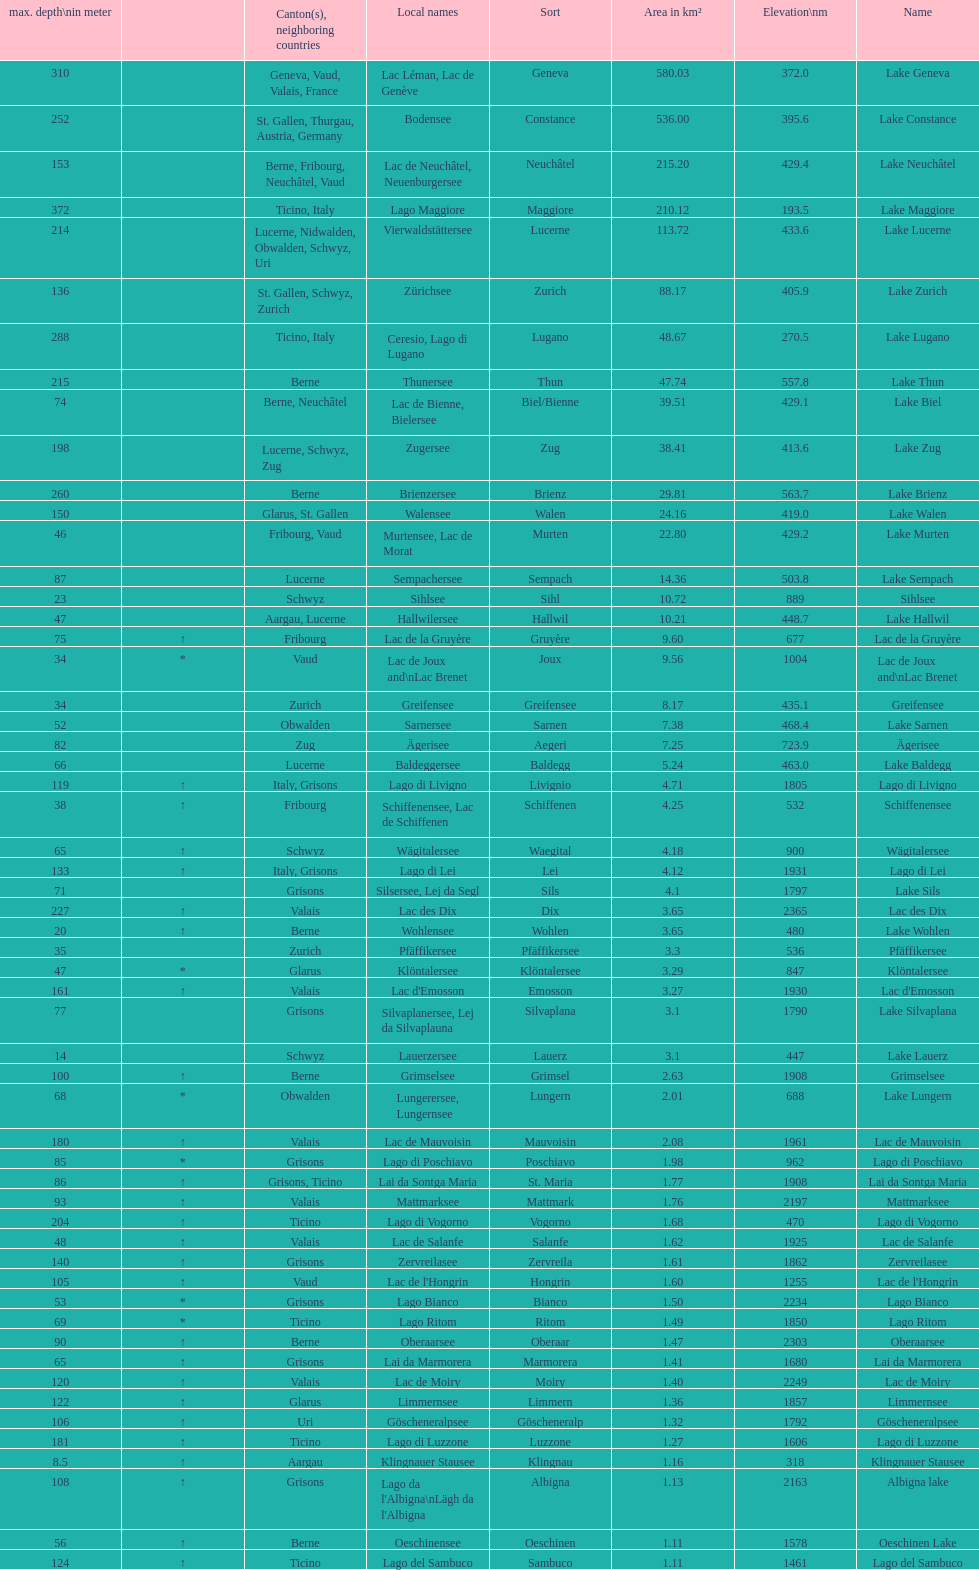Name the largest lake Lake Geneva. 